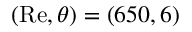<formula> <loc_0><loc_0><loc_500><loc_500>( R e , \theta ) = ( 6 5 0 , 6 )</formula> 